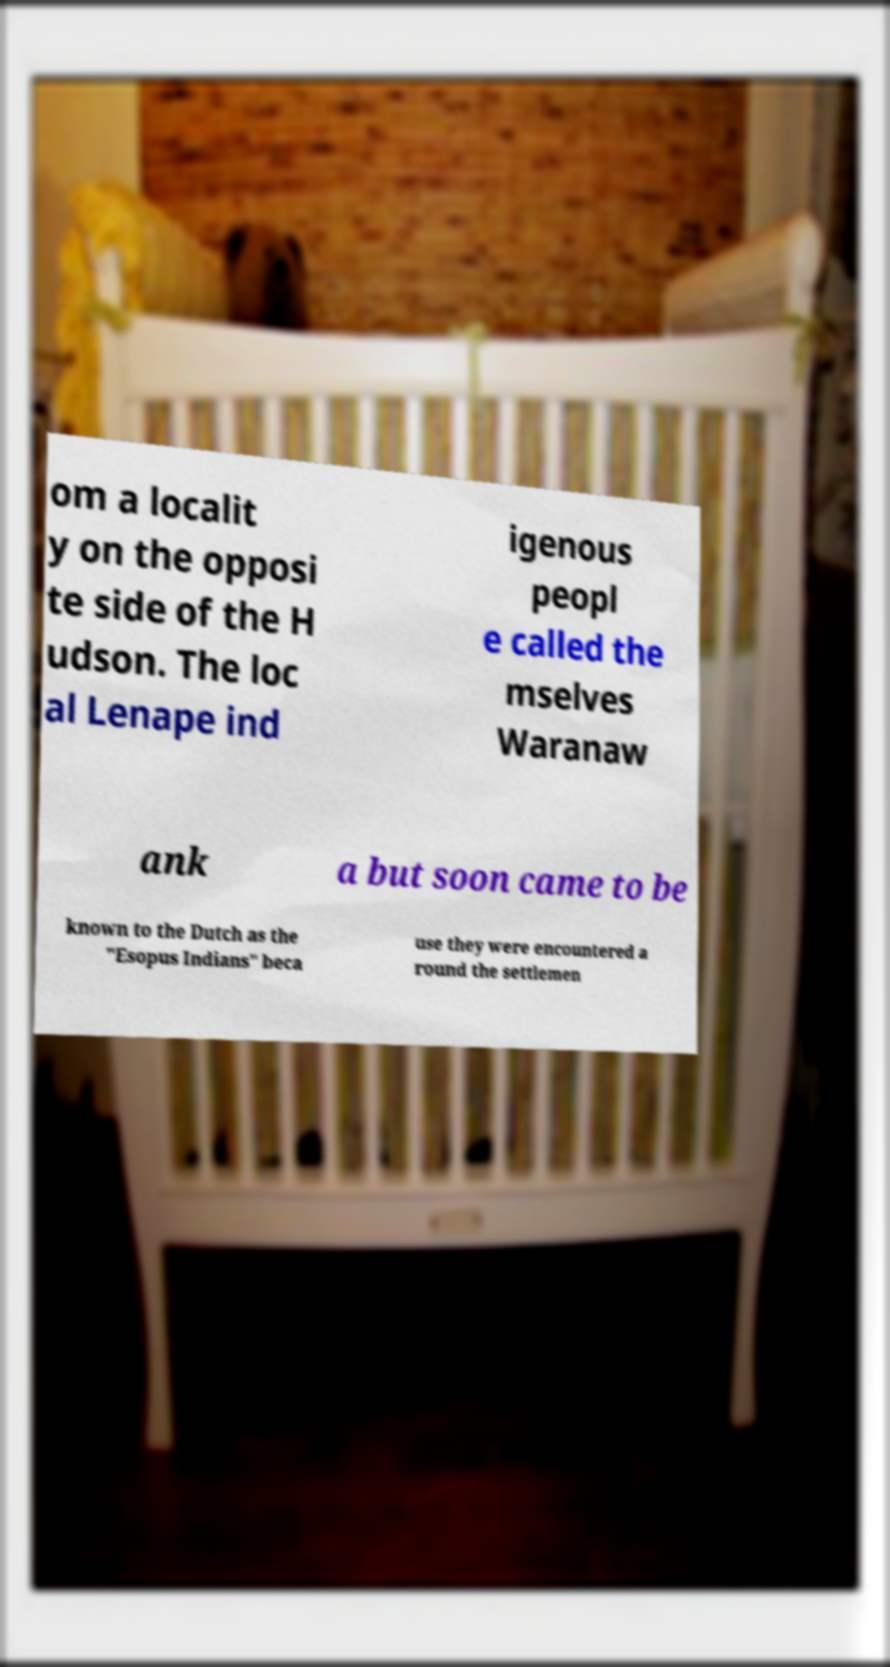Can you accurately transcribe the text from the provided image for me? om a localit y on the opposi te side of the H udson. The loc al Lenape ind igenous peopl e called the mselves Waranaw ank a but soon came to be known to the Dutch as the "Esopus Indians" beca use they were encountered a round the settlemen 